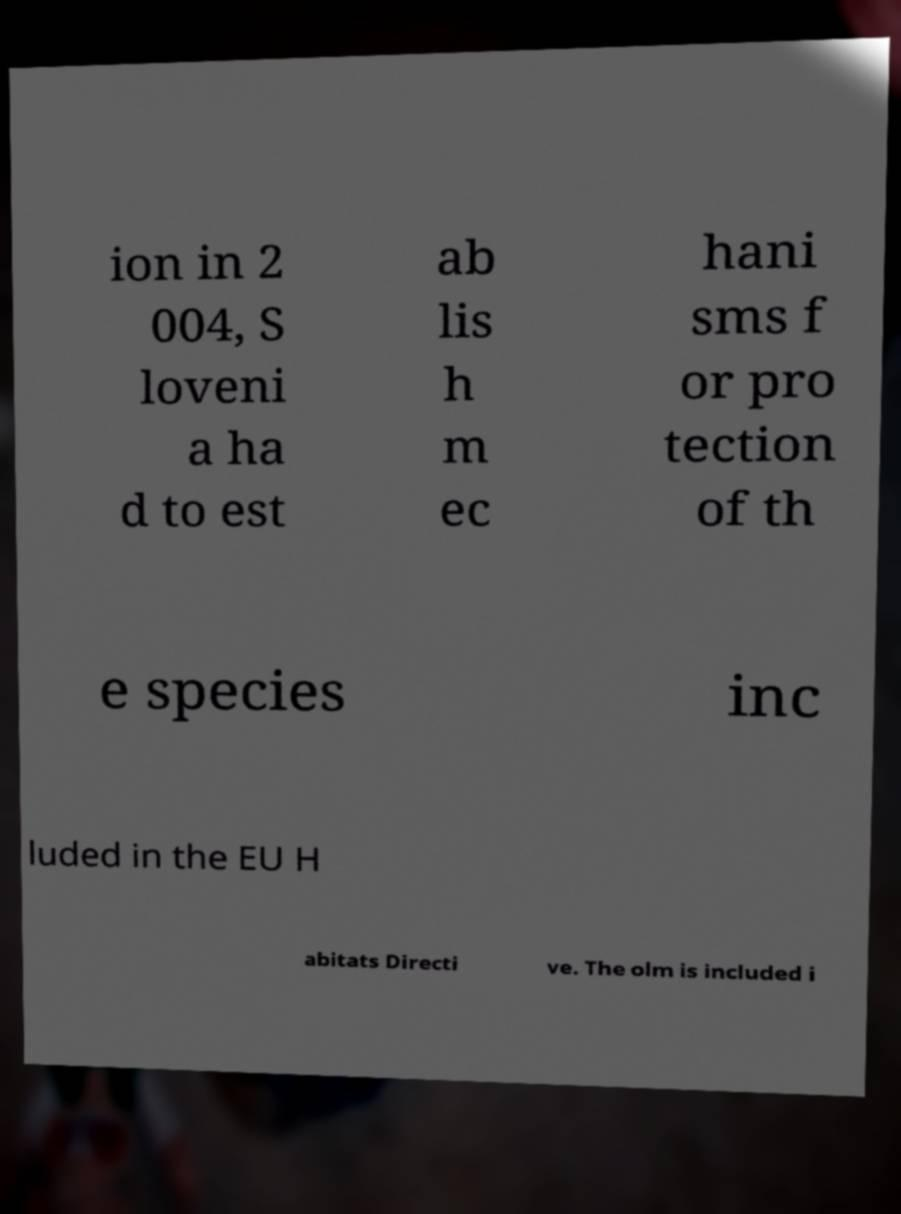Please identify and transcribe the text found in this image. ion in 2 004, S loveni a ha d to est ab lis h m ec hani sms f or pro tection of th e species inc luded in the EU H abitats Directi ve. The olm is included i 